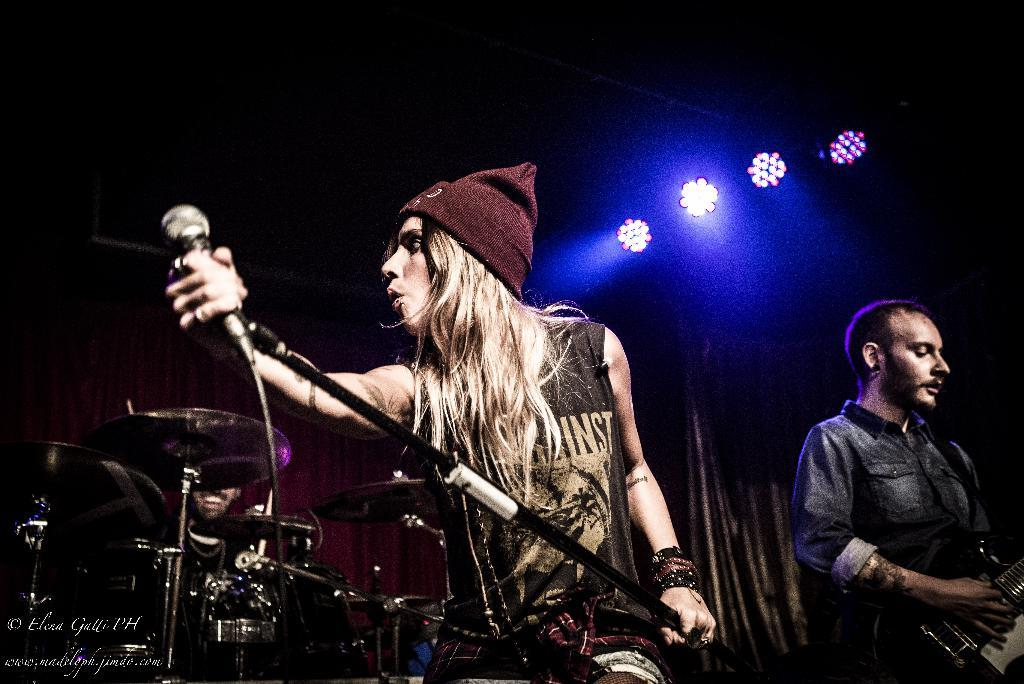What type of lights are present in the image? There are focusing lights in the image. What is the man standing and doing in the image? The man is standing and playing a guitar. What is the woman holding in the image? The woman is holding a mic and a wire cap. How many men are playing musical instruments in the image? There is at least one man playing musical instruments in the image. Can you tell me how many letters are on the tray in the image? There is no tray or letters present in the image. What type of visitor can be seen interacting with the guitarist in the image? There is no visitor present in the image; only a man playing a guitar and a woman holding a mic and a wire cap are visible. 